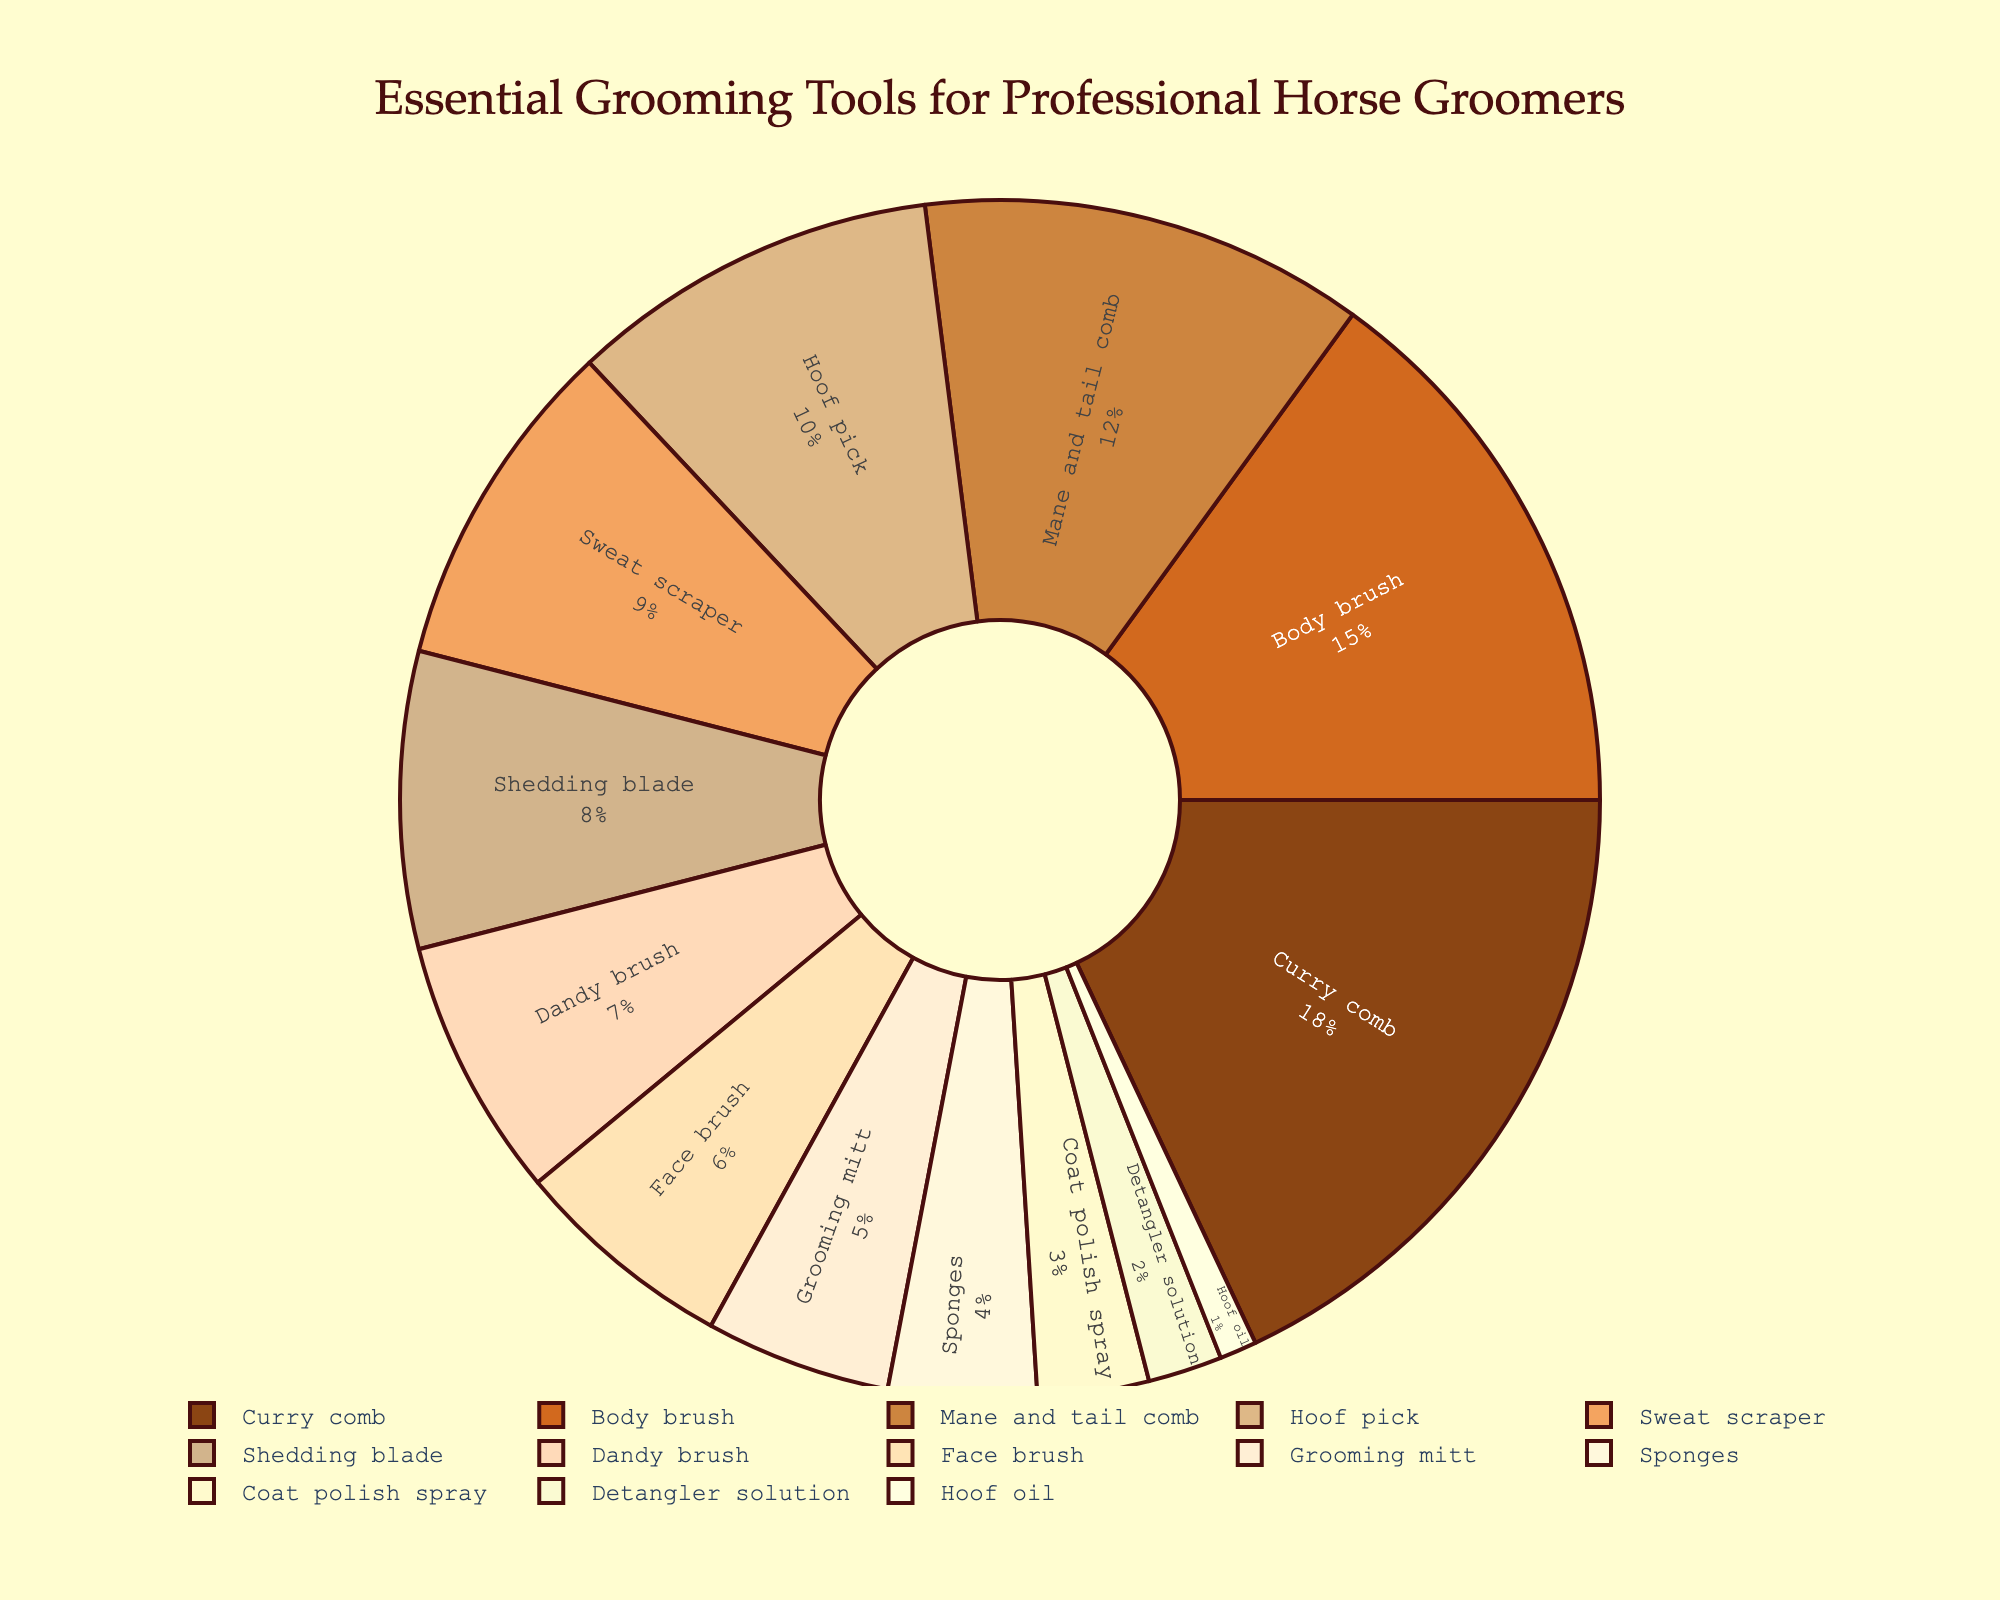Which grooming tool is used the most by professional horse groomers? The largest section of the pie chart represents the tool with the highest percentage. The curry comb has the largest section at 18%.
Answer: Curry comb What is the combined percentage of the body brush and the mane and tail comb? Add the percentages of the body brush and the mane and tail comb: 15% (body brush) + 12% (mane and tail comb) = 27%.
Answer: 27% Which tool has a lower usage percentage, the shedding blade or the detangler solution? Compare the percentages of the shedding blade (8%) and the detangler solution (2%). The detangler solution has a lower percentage.
Answer: Detangler solution How much more frequently is the curry comb used compared to the hoof pick? Subtract the percentage of the hoof pick from the percentage of the curry comb: 18% (curry comb) - 10% (hoof pick) = 8%.
Answer: 8% Which tool is represented by the lightest color in the pie chart? The pie chart uses progressively darker shades for higher percentages. The hoof oil has the smallest section and thus the lightest color.
Answer: Hoof oil What is the combined percentage for all tools that make up 10% or more of the usage? Add the percentages of the curry comb (18%), body brush (15%), and mane and tail comb (12%): 18% + 15% + 12% = 45%.
Answer: 45% Rank the tools with usage percentages of 5% or less from highest to lowest. The tools with percentages of 5% or less are grooming mitt (5%), sponges (4%), coat polish spray (3%), detangler solution (2%), and hoof oil (1%). Rank them from 5% to 1%.
Answer: Grooming mitt > Sponges > Coat polish spray > Detangler solution > Hoof oil If the sweat scraper and the dandy brush were combined into one category, what would be their combined percentage? Add the percentages of the sweat scraper (9%) and the dandy brush (7%): 9% + 7% = 16%.
Answer: 16% 